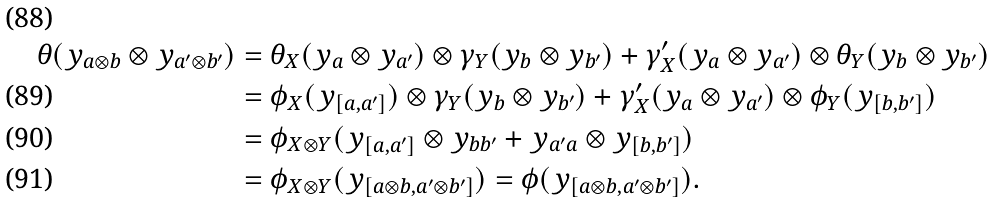Convert formula to latex. <formula><loc_0><loc_0><loc_500><loc_500>\theta ( y _ { a \otimes b } \otimes y _ { a ^ { \prime } \otimes b ^ { \prime } } ) & = \theta _ { X } ( y _ { a } \otimes y _ { a ^ { \prime } } ) \otimes \gamma _ { Y } ( y _ { b } \otimes y _ { b ^ { \prime } } ) + \gamma ^ { \prime } _ { X } ( y _ { a } \otimes y _ { a ^ { \prime } } ) \otimes \theta _ { Y } ( y _ { b } \otimes y _ { b ^ { \prime } } ) \\ & = \phi _ { X } ( y _ { [ a , a ^ { \prime } ] } ) \otimes \gamma _ { Y } ( y _ { b } \otimes y _ { b ^ { \prime } } ) + \gamma ^ { \prime } _ { X } ( y _ { a } \otimes y _ { a ^ { \prime } } ) \otimes \phi _ { Y } ( y _ { [ b , b ^ { \prime } ] } ) \\ & = \phi _ { X \otimes Y } ( y _ { [ a , a ^ { \prime } ] } \otimes y _ { b b ^ { \prime } } + y _ { a ^ { \prime } a } \otimes y _ { [ b , b ^ { \prime } ] } ) \\ & = \phi _ { X \otimes Y } ( y _ { [ a \otimes b , a ^ { \prime } \otimes b ^ { \prime } ] } ) = \phi ( y _ { [ a \otimes b , a ^ { \prime } \otimes b ^ { \prime } ] } ) .</formula> 